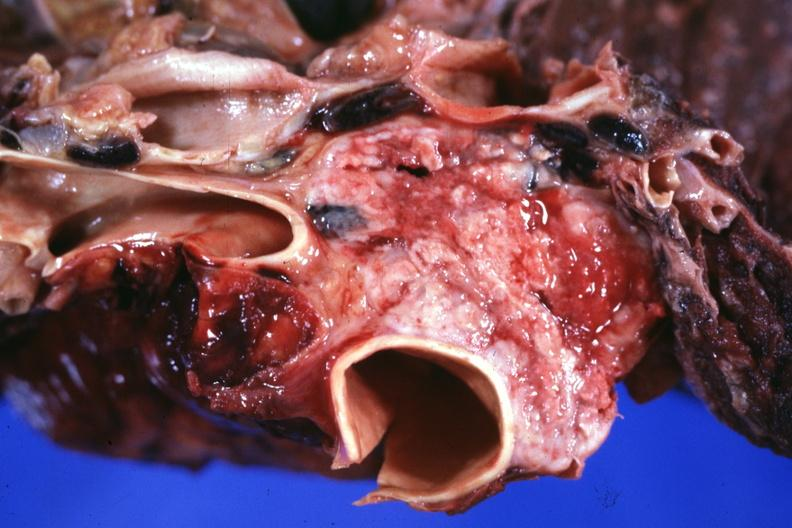what is present?
Answer the question using a single word or phrase. Hematologic 